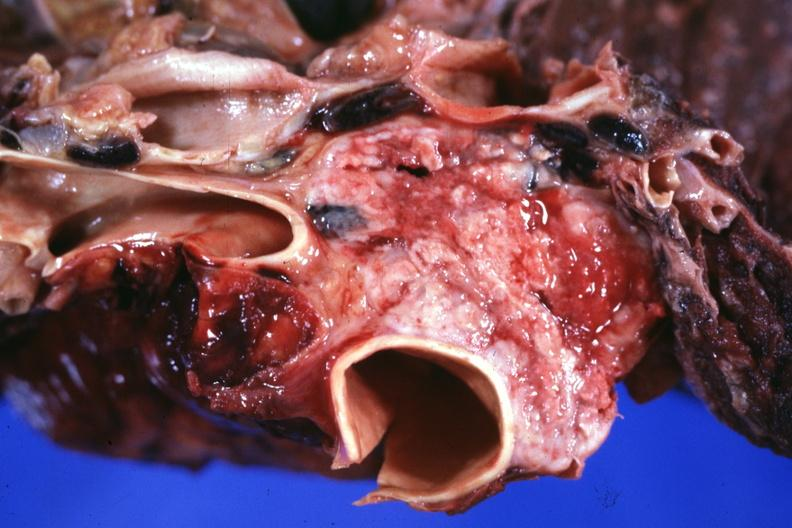what is present?
Answer the question using a single word or phrase. Hematologic 